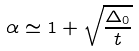<formula> <loc_0><loc_0><loc_500><loc_500>\alpha \simeq 1 + \sqrt { \frac { \Delta _ { 0 } } { t } }</formula> 